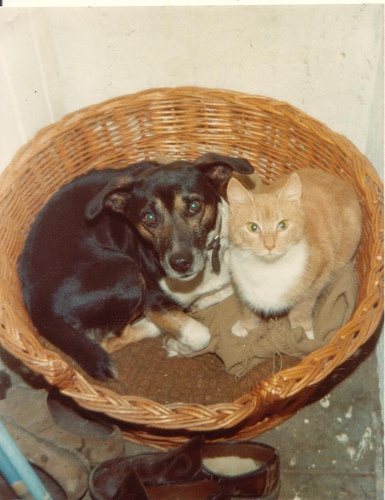Describe the objects in this image and their specific colors. I can see dog in black, maroon, and gray tones and cat in black and tan tones in this image. 